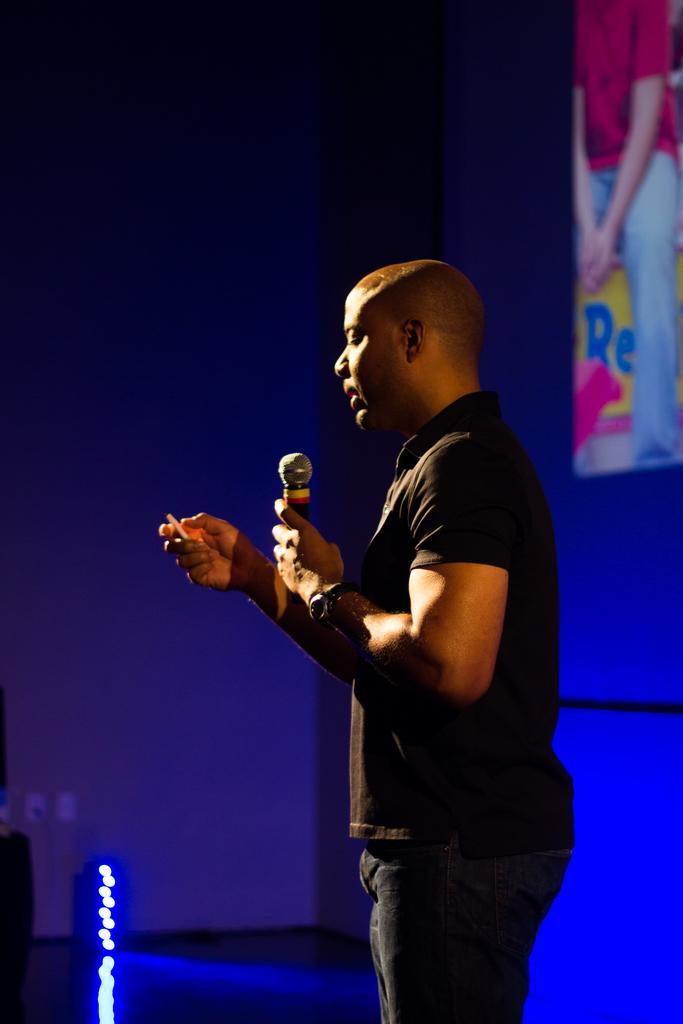In one or two sentences, can you explain what this image depicts? In the picture we can see a man holding a microphone and standing and he is wearing a T-shirt which is black in color with a bald head and in the background, we can see a wall and blue color focus light on it and in the top of the wall we can see a hoarding with a person image on it. 